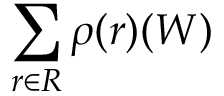<formula> <loc_0><loc_0><loc_500><loc_500>\sum _ { r \in R } \rho ( r ) ( W )</formula> 